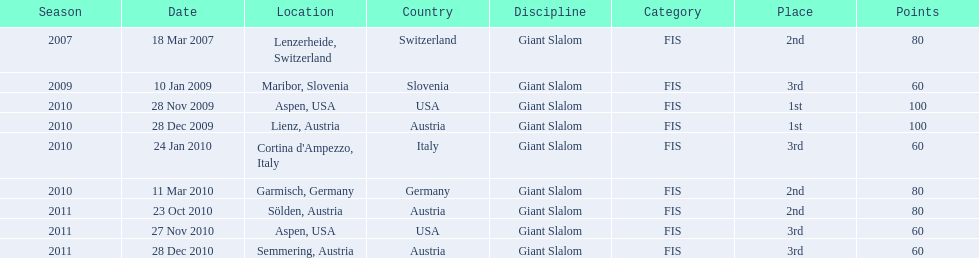Would you mind parsing the complete table? {'header': ['Season', 'Date', 'Location', 'Country', 'Discipline', 'Category', 'Place', 'Points'], 'rows': [['2007', '18 Mar 2007', 'Lenzerheide, Switzerland', 'Switzerland', 'Giant Slalom', 'FIS', '2nd', '80'], ['2009', '10 Jan 2009', 'Maribor, Slovenia', 'Slovenia', 'Giant Slalom', 'FIS', '3rd', '60'], ['2010', '28 Nov 2009', 'Aspen, USA', 'USA', 'Giant Slalom', 'FIS', '1st', '100'], ['2010', '28 Dec 2009', 'Lienz, Austria', 'Austria', 'Giant Slalom', 'FIS', '1st', '100'], ['2010', '24 Jan 2010', "Cortina d'Ampezzo, Italy", 'Italy', 'Giant Slalom', 'FIS', '3rd', '60'], ['2010', '11 Mar 2010', 'Garmisch, Germany', 'Germany', 'Giant Slalom', 'FIS', '2nd', '80'], ['2011', '23 Oct 2010', 'Sölden, Austria', 'Austria', 'Giant Slalom', 'FIS', '2nd', '80'], ['2011', '27 Nov 2010', 'Aspen, USA', 'USA', 'Giant Slalom', 'FIS', '3rd', '60'], ['2011', '28 Dec 2010', 'Semmering, Austria', 'Austria', 'Giant Slalom', 'FIS', '3rd', '60']]} Aspen and lienz in 2009 are the only races where this racer got what position? 1st. 